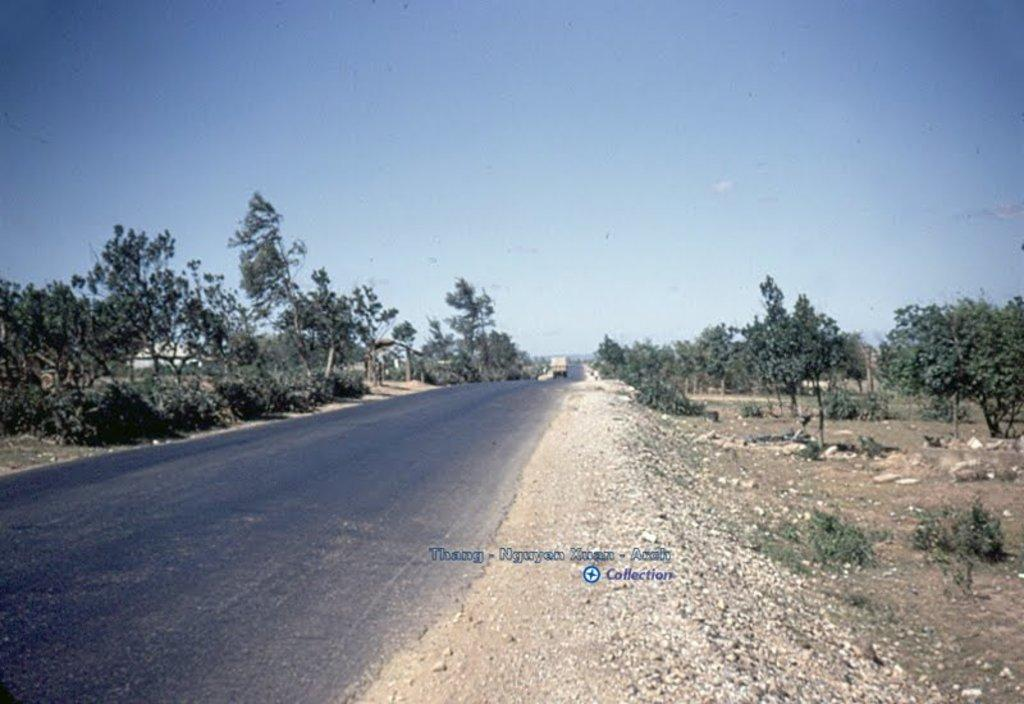What is the main feature of the image? There is a road in the image. What can be seen on the road? There is a truck on the road. What type of vegetation is visible in the image? There are trees visible in the image. What is visible at the top of the image? The sky is visible at the top of the image. Where is the queen standing in the image? There is no queen present in the image. What type of power is being generated by the truck in the image? The image does not provide information about the truck's power generation capabilities. 